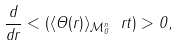Convert formula to latex. <formula><loc_0><loc_0><loc_500><loc_500>\frac { d } { d r } < ( \langle \Theta ( r ) \rangle _ { { \mathcal { M } } _ { 0 } ^ { n } } \ r t ) > 0 ,</formula> 